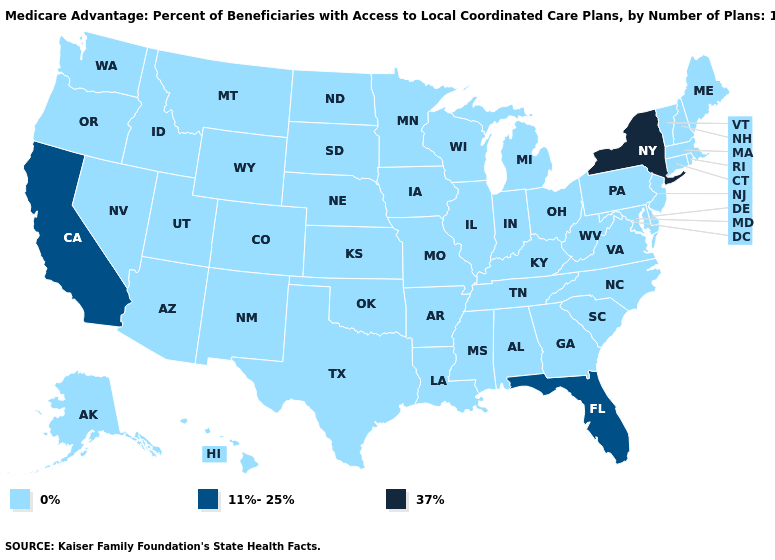What is the value of New Hampshire?
Write a very short answer. 0%. How many symbols are there in the legend?
Short answer required. 3. Name the states that have a value in the range 0%?
Short answer required. Alaska, Alabama, Arkansas, Arizona, Colorado, Connecticut, Delaware, Georgia, Hawaii, Iowa, Idaho, Illinois, Indiana, Kansas, Kentucky, Louisiana, Massachusetts, Maryland, Maine, Michigan, Minnesota, Missouri, Mississippi, Montana, North Carolina, North Dakota, Nebraska, New Hampshire, New Jersey, New Mexico, Nevada, Ohio, Oklahoma, Oregon, Pennsylvania, Rhode Island, South Carolina, South Dakota, Tennessee, Texas, Utah, Virginia, Vermont, Washington, Wisconsin, West Virginia, Wyoming. Among the states that border Nevada , which have the highest value?
Concise answer only. California. Does the first symbol in the legend represent the smallest category?
Give a very brief answer. Yes. Name the states that have a value in the range 37%?
Answer briefly. New York. What is the lowest value in the USA?
Concise answer only. 0%. What is the value of Mississippi?
Answer briefly. 0%. What is the value of South Dakota?
Keep it brief. 0%. Does Georgia have the same value as Washington?
Answer briefly. Yes. What is the value of New Hampshire?
Quick response, please. 0%. Name the states that have a value in the range 0%?
Write a very short answer. Alaska, Alabama, Arkansas, Arizona, Colorado, Connecticut, Delaware, Georgia, Hawaii, Iowa, Idaho, Illinois, Indiana, Kansas, Kentucky, Louisiana, Massachusetts, Maryland, Maine, Michigan, Minnesota, Missouri, Mississippi, Montana, North Carolina, North Dakota, Nebraska, New Hampshire, New Jersey, New Mexico, Nevada, Ohio, Oklahoma, Oregon, Pennsylvania, Rhode Island, South Carolina, South Dakota, Tennessee, Texas, Utah, Virginia, Vermont, Washington, Wisconsin, West Virginia, Wyoming. Name the states that have a value in the range 11%-25%?
Write a very short answer. California, Florida. Does Utah have the highest value in the USA?
Quick response, please. No. 